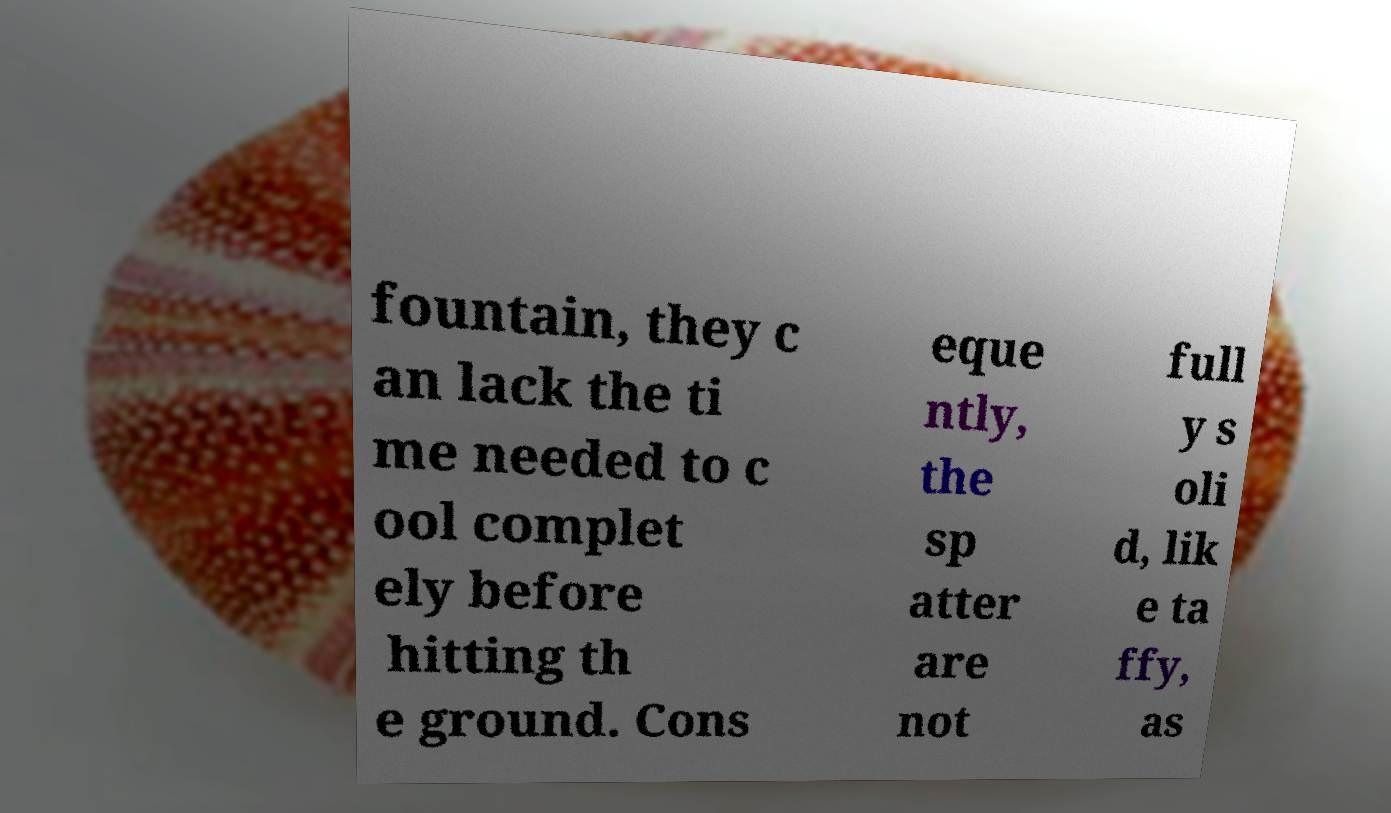There's text embedded in this image that I need extracted. Can you transcribe it verbatim? fountain, they c an lack the ti me needed to c ool complet ely before hitting th e ground. Cons eque ntly, the sp atter are not full y s oli d, lik e ta ffy, as 